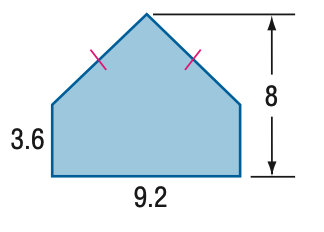Answer the mathemtical geometry problem and directly provide the correct option letter.
Question: Find the area of the figure. Round to the nearest tenth if necessary.
Choices: A: 52.4 B: 53.4 C: 57.6 D: 73.6 B 